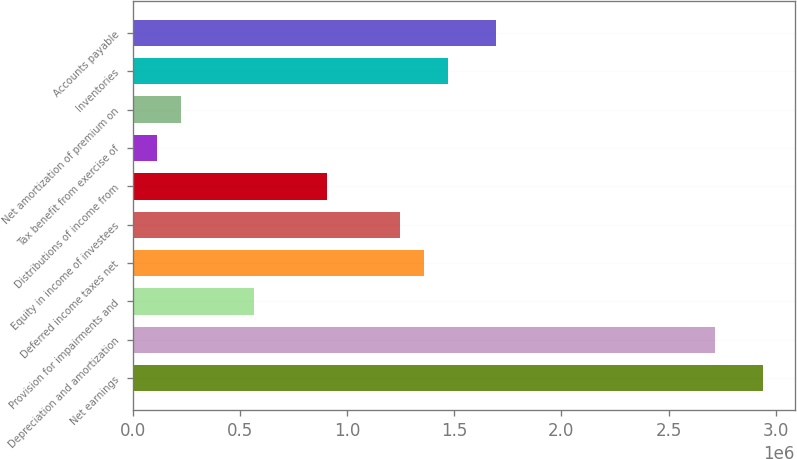Convert chart. <chart><loc_0><loc_0><loc_500><loc_500><bar_chart><fcel>Net earnings<fcel>Depreciation and amortization<fcel>Provision for impairments and<fcel>Deferred income taxes net<fcel>Equity in income of investees<fcel>Distributions of income from<fcel>Tax benefit from exercise of<fcel>Net amortization of premium on<fcel>Inventories<fcel>Accounts payable<nl><fcel>2.94081e+06<fcel>2.71466e+06<fcel>566266<fcel>1.35778e+06<fcel>1.24471e+06<fcel>905486<fcel>113972<fcel>227045<fcel>1.47085e+06<fcel>1.697e+06<nl></chart> 